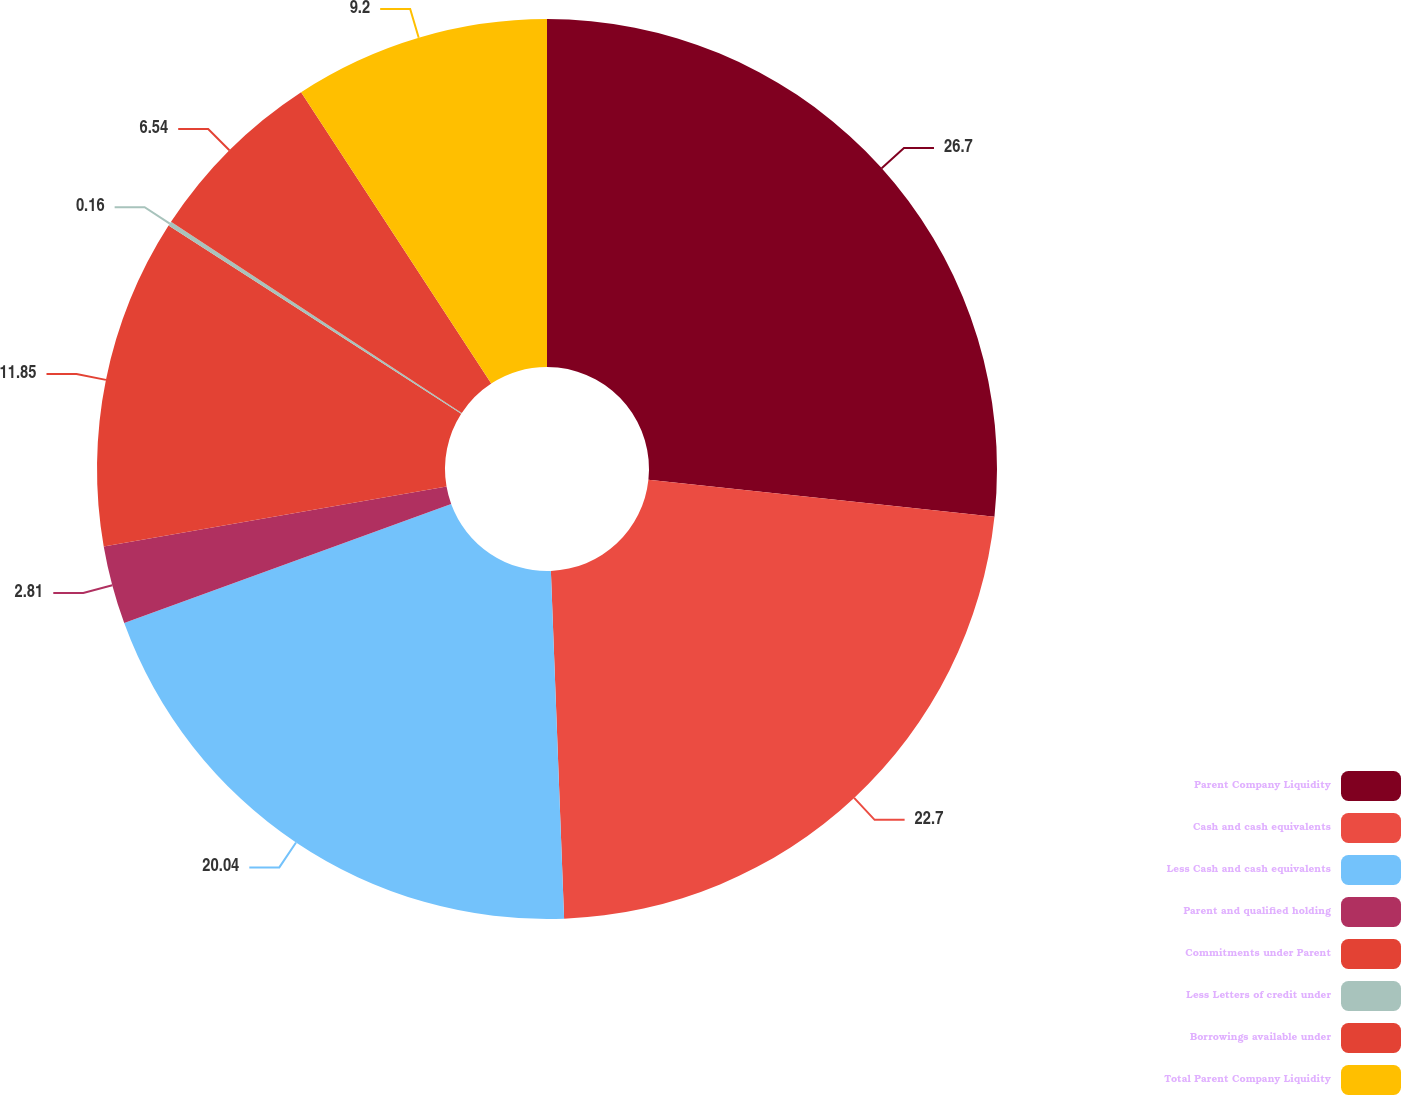Convert chart. <chart><loc_0><loc_0><loc_500><loc_500><pie_chart><fcel>Parent Company Liquidity<fcel>Cash and cash equivalents<fcel>Less Cash and cash equivalents<fcel>Parent and qualified holding<fcel>Commitments under Parent<fcel>Less Letters of credit under<fcel>Borrowings available under<fcel>Total Parent Company Liquidity<nl><fcel>26.69%<fcel>22.7%<fcel>20.04%<fcel>2.81%<fcel>11.85%<fcel>0.16%<fcel>6.54%<fcel>9.2%<nl></chart> 